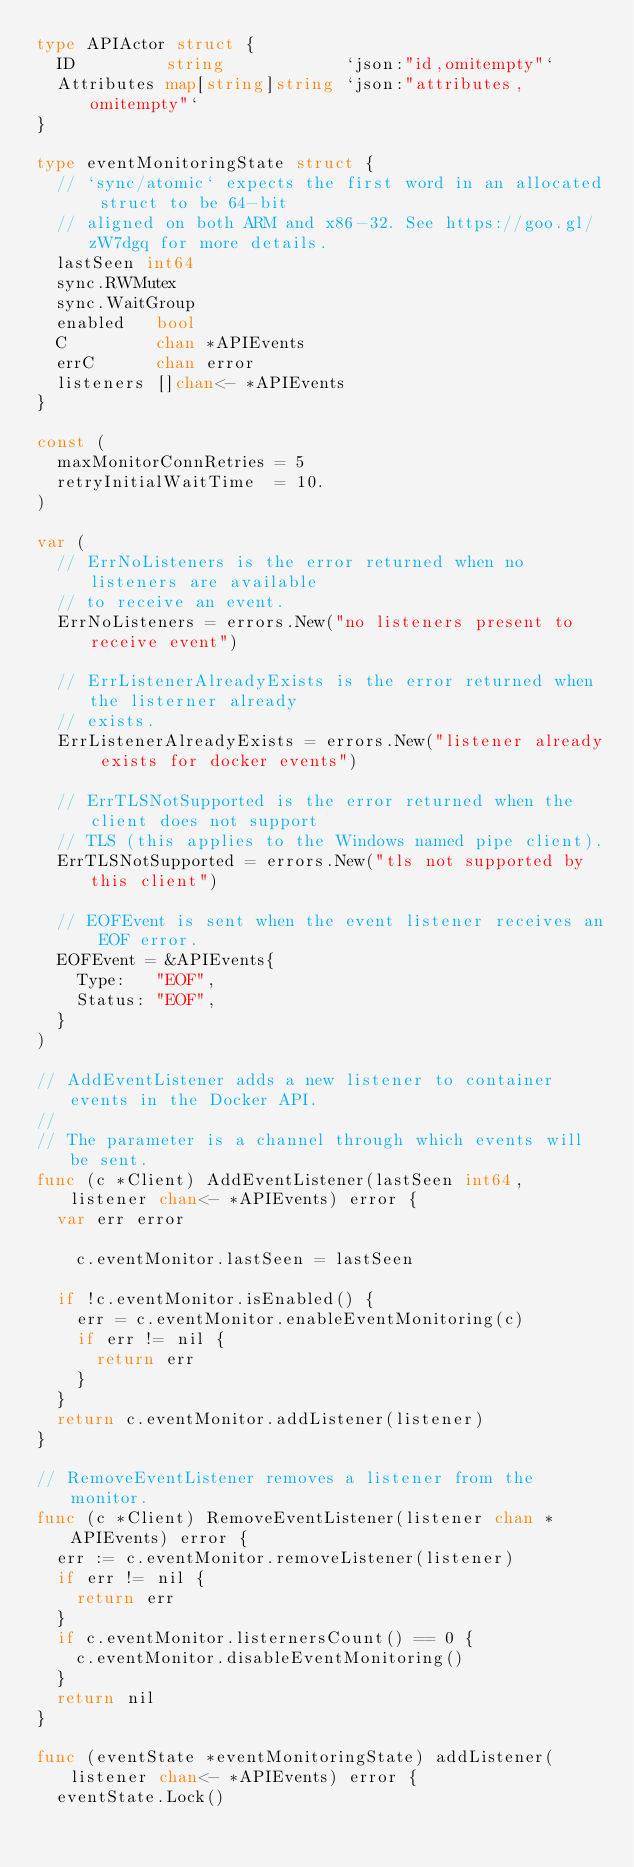<code> <loc_0><loc_0><loc_500><loc_500><_Go_>type APIActor struct {
	ID         string            `json:"id,omitempty"`
	Attributes map[string]string `json:"attributes,omitempty"`
}

type eventMonitoringState struct {
	// `sync/atomic` expects the first word in an allocated struct to be 64-bit
	// aligned on both ARM and x86-32. See https://goo.gl/zW7dgq for more details.
	lastSeen int64
	sync.RWMutex
	sync.WaitGroup
	enabled   bool
	C         chan *APIEvents
	errC      chan error
	listeners []chan<- *APIEvents
}

const (
	maxMonitorConnRetries = 5
	retryInitialWaitTime  = 10.
)

var (
	// ErrNoListeners is the error returned when no listeners are available
	// to receive an event.
	ErrNoListeners = errors.New("no listeners present to receive event")

	// ErrListenerAlreadyExists is the error returned when the listerner already
	// exists.
	ErrListenerAlreadyExists = errors.New("listener already exists for docker events")

	// ErrTLSNotSupported is the error returned when the client does not support
	// TLS (this applies to the Windows named pipe client).
	ErrTLSNotSupported = errors.New("tls not supported by this client")

	// EOFEvent is sent when the event listener receives an EOF error.
	EOFEvent = &APIEvents{
		Type:   "EOF",
		Status: "EOF",
	}
)

// AddEventListener adds a new listener to container events in the Docker API.
//
// The parameter is a channel through which events will be sent.
func (c *Client) AddEventListener(lastSeen int64, listener chan<- *APIEvents) error {
	var err error

		c.eventMonitor.lastSeen = lastSeen

	if !c.eventMonitor.isEnabled() {
		err = c.eventMonitor.enableEventMonitoring(c)
		if err != nil {
			return err
		}
	}
	return c.eventMonitor.addListener(listener)
}

// RemoveEventListener removes a listener from the monitor.
func (c *Client) RemoveEventListener(listener chan *APIEvents) error {
	err := c.eventMonitor.removeListener(listener)
	if err != nil {
		return err
	}
	if c.eventMonitor.listernersCount() == 0 {
		c.eventMonitor.disableEventMonitoring()
	}
	return nil
}

func (eventState *eventMonitoringState) addListener(listener chan<- *APIEvents) error {
	eventState.Lock()</code> 